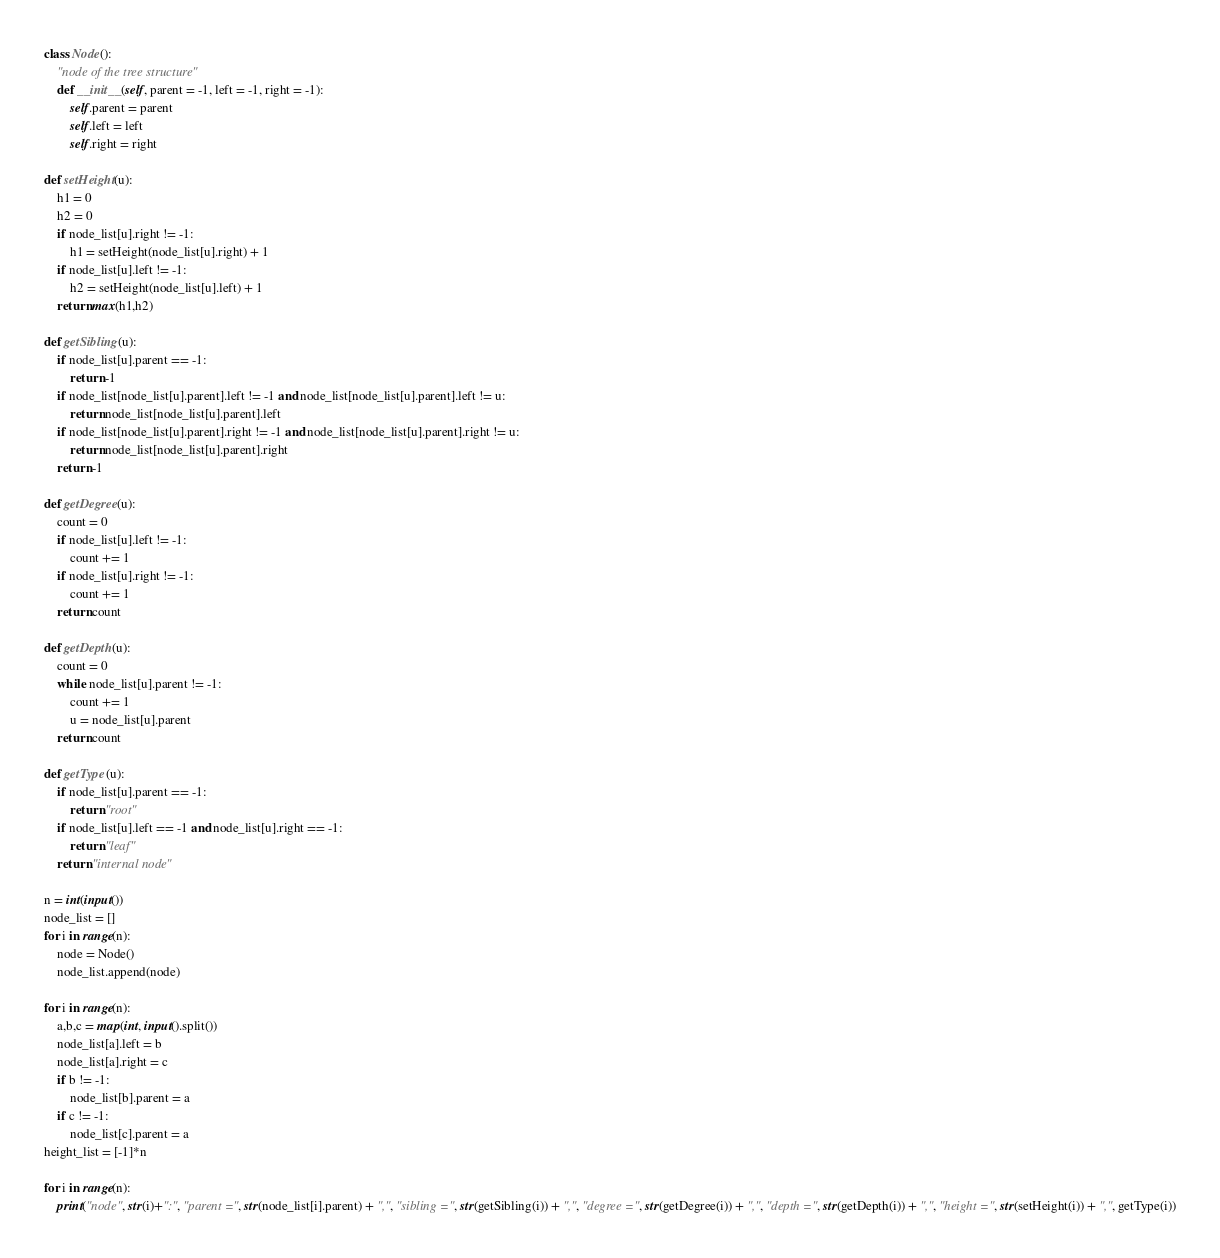Convert code to text. <code><loc_0><loc_0><loc_500><loc_500><_Python_>
class Node():
    "node of the tree structure"
    def __init__(self, parent = -1, left = -1, right = -1):
        self.parent = parent
        self.left = left
        self.right = right

def setHeight(u):
    h1 = 0
    h2 = 0
    if node_list[u].right != -1:
        h1 = setHeight(node_list[u].right) + 1
    if node_list[u].left != -1:
        h2 = setHeight(node_list[u].left) + 1
    return max(h1,h2)

def getSibling(u):
    if node_list[u].parent == -1:
        return -1
    if node_list[node_list[u].parent].left != -1 and node_list[node_list[u].parent].left != u:
        return node_list[node_list[u].parent].left
    if node_list[node_list[u].parent].right != -1 and node_list[node_list[u].parent].right != u:
        return node_list[node_list[u].parent].right
    return -1

def getDegree(u):
    count = 0
    if node_list[u].left != -1:
        count += 1
    if node_list[u].right != -1:
        count += 1
    return count

def getDepth(u):
    count = 0
    while node_list[u].parent != -1:
        count += 1
        u = node_list[u].parent
    return count

def getType(u):
    if node_list[u].parent == -1:
        return "root"
    if node_list[u].left == -1 and node_list[u].right == -1:
        return "leaf"
    return "internal node"

n = int(input())
node_list = []
for i in range(n):
    node = Node()
    node_list.append(node)

for i in range(n):
    a,b,c = map(int, input().split())
    node_list[a].left = b
    node_list[a].right = c
    if b != -1:
        node_list[b].parent = a
    if c != -1:
        node_list[c].parent = a
height_list = [-1]*n

for i in range(n):
    print("node", str(i)+":", "parent =", str(node_list[i].parent) + ",", "sibling =", str(getSibling(i)) + ",", "degree =", str(getDegree(i)) + ",", "depth =", str(getDepth(i)) + ",", "height =", str(setHeight(i)) + ",", getType(i))

</code> 